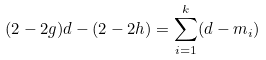Convert formula to latex. <formula><loc_0><loc_0><loc_500><loc_500>( 2 - 2 g ) d - ( 2 - 2 h ) = \sum _ { i = 1 } ^ { k } ( d - m _ { i } )</formula> 